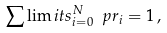Convert formula to latex. <formula><loc_0><loc_0><loc_500><loc_500>\sum \lim i t s _ { i = 0 } ^ { N } \ p r _ { i } = 1 \, ,</formula> 